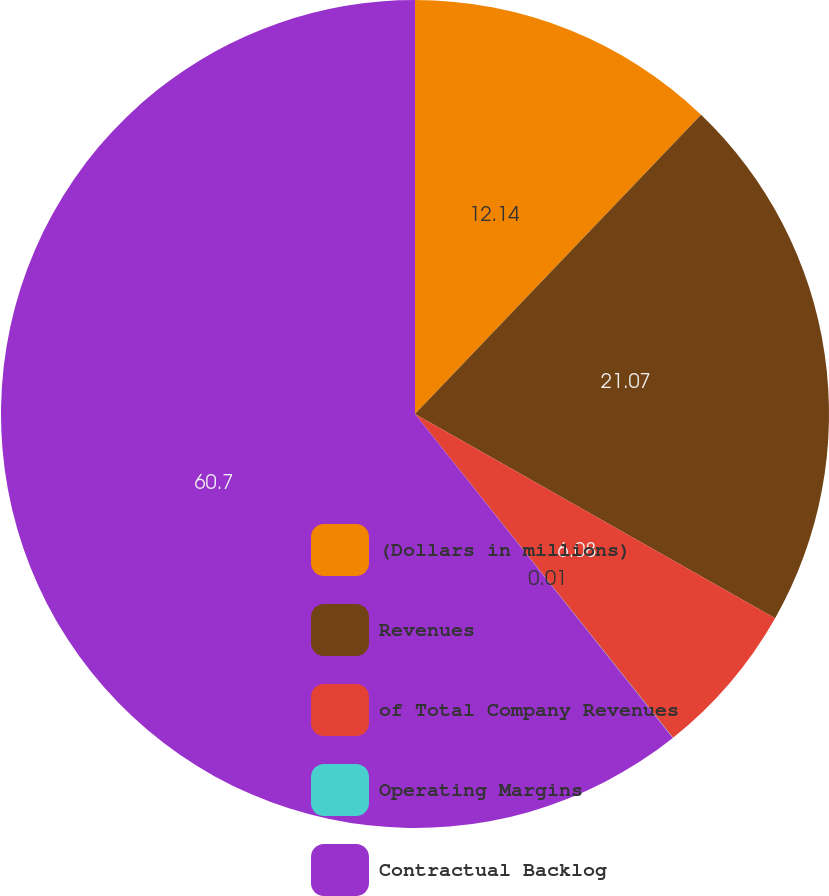<chart> <loc_0><loc_0><loc_500><loc_500><pie_chart><fcel>(Dollars in millions)<fcel>Revenues<fcel>of Total Company Revenues<fcel>Operating Margins<fcel>Contractual Backlog<nl><fcel>12.14%<fcel>21.07%<fcel>6.08%<fcel>0.01%<fcel>60.7%<nl></chart> 